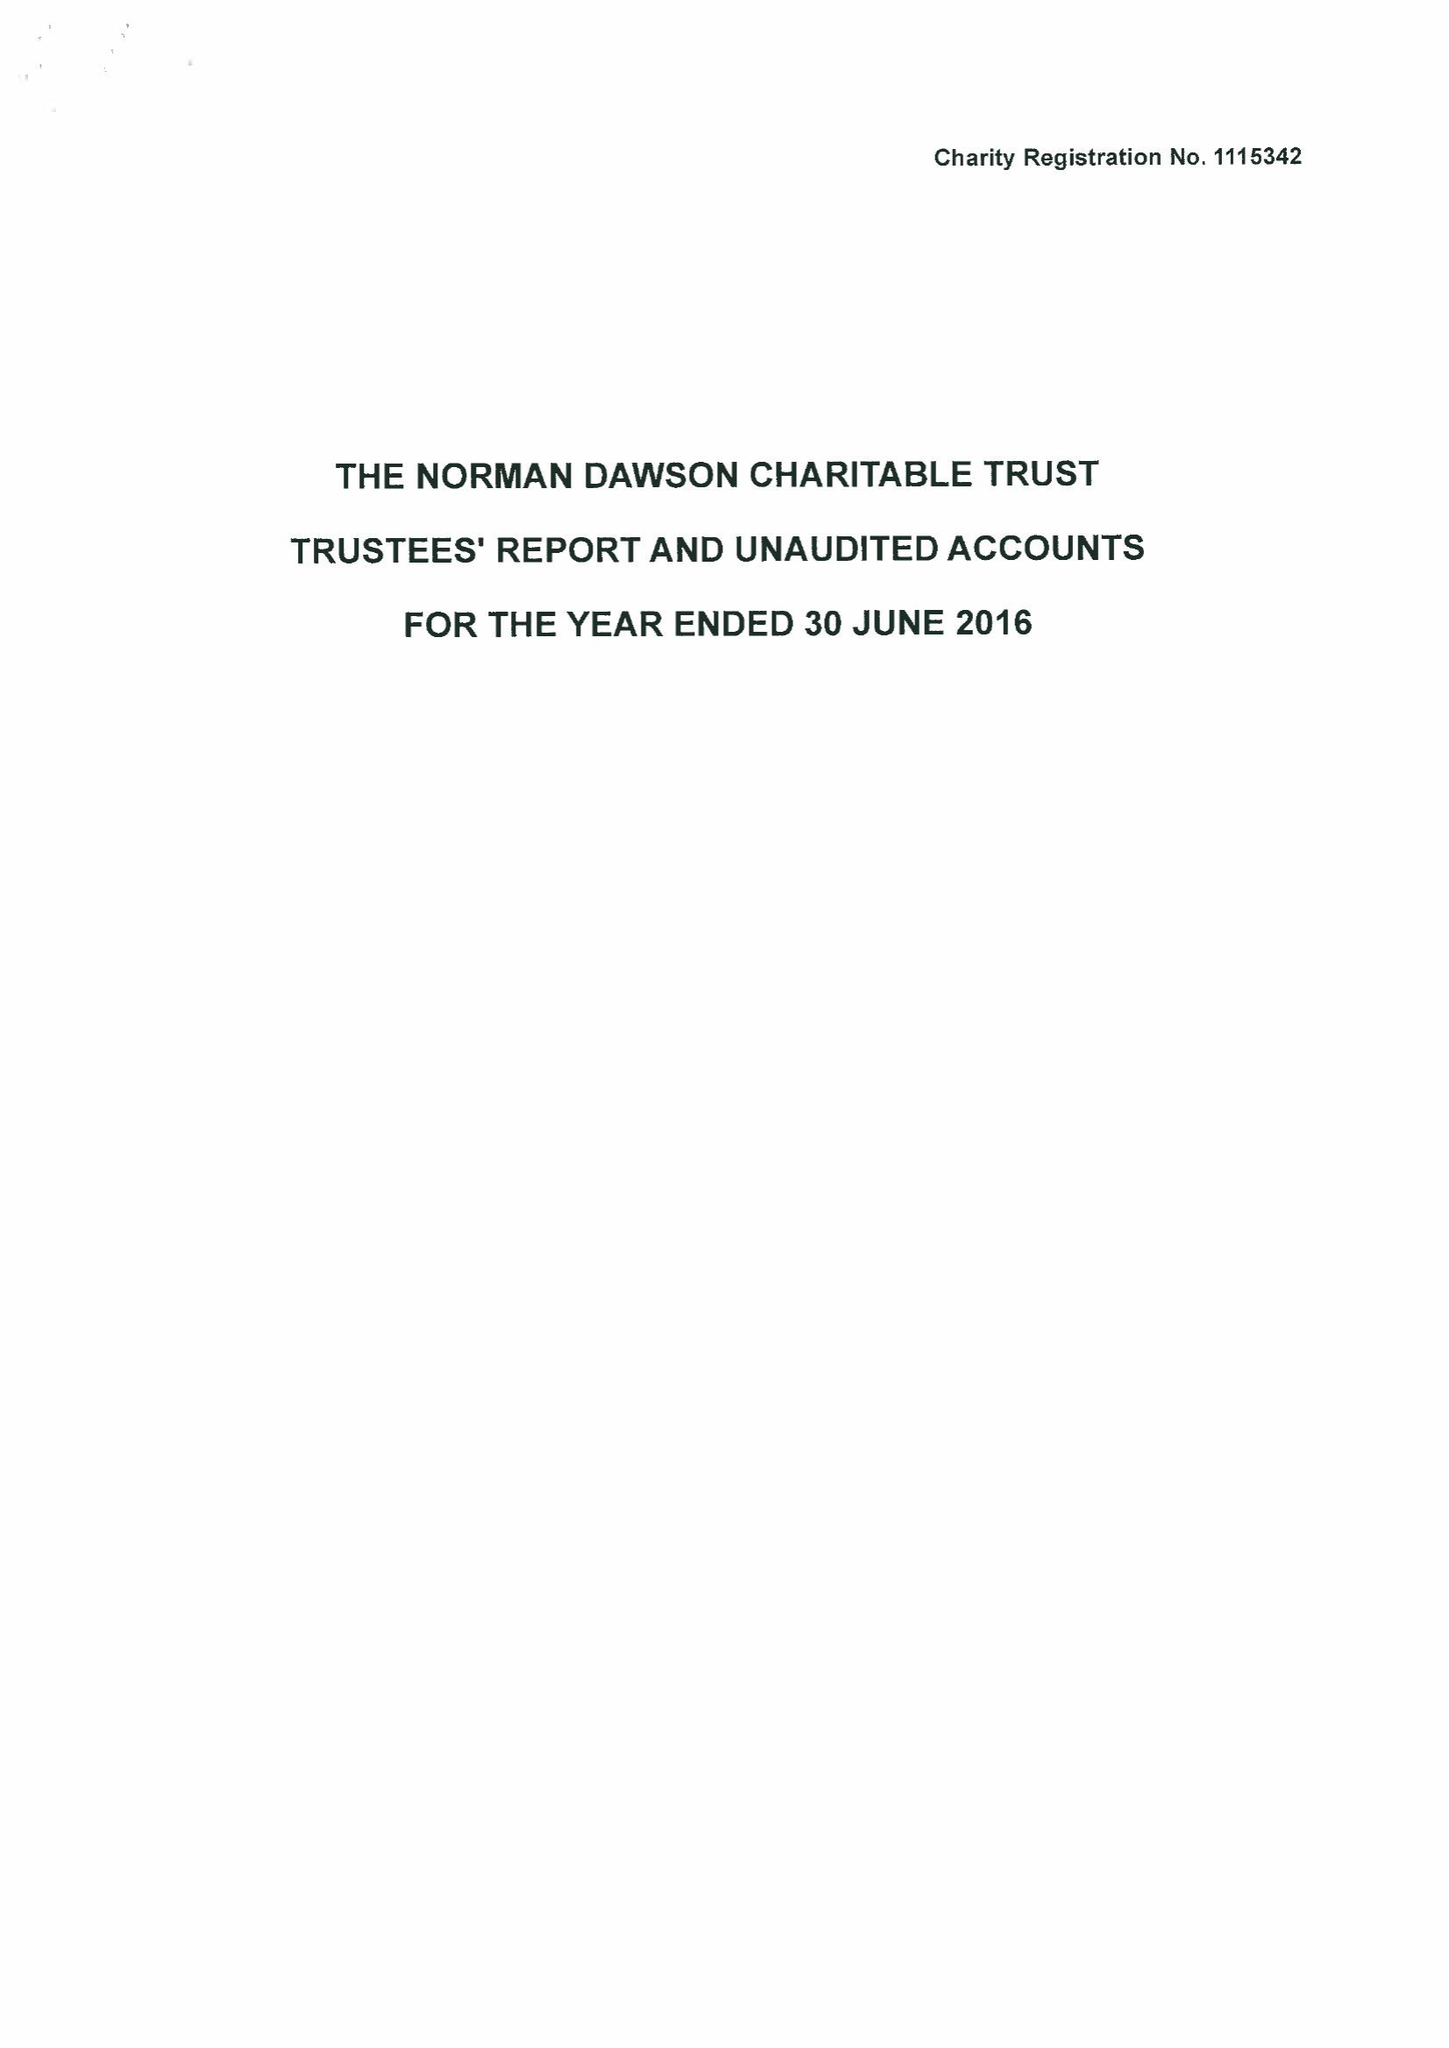What is the value for the address__postcode?
Answer the question using a single word or phrase. DY10 2SA 